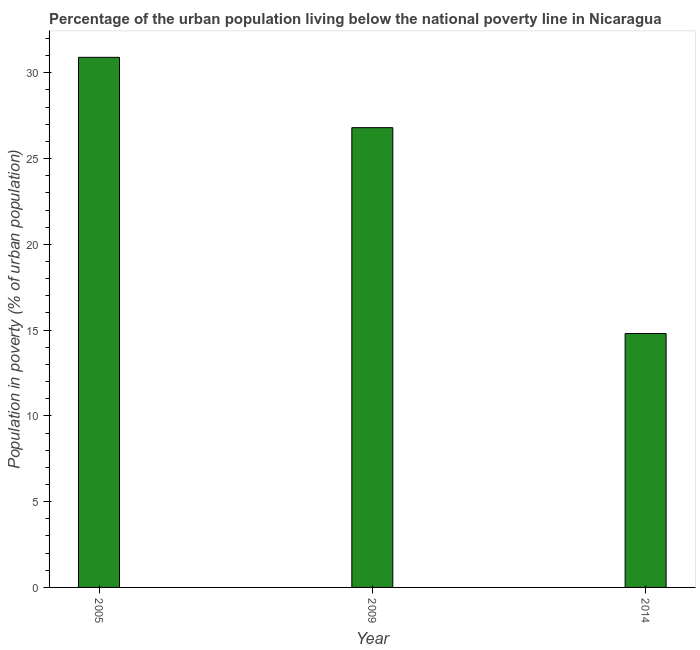What is the title of the graph?
Ensure brevity in your answer.  Percentage of the urban population living below the national poverty line in Nicaragua. What is the label or title of the Y-axis?
Offer a very short reply. Population in poverty (% of urban population). What is the percentage of urban population living below poverty line in 2009?
Ensure brevity in your answer.  26.8. Across all years, what is the maximum percentage of urban population living below poverty line?
Make the answer very short. 30.9. Across all years, what is the minimum percentage of urban population living below poverty line?
Your answer should be compact. 14.8. In which year was the percentage of urban population living below poverty line maximum?
Make the answer very short. 2005. What is the sum of the percentage of urban population living below poverty line?
Your response must be concise. 72.5. What is the difference between the percentage of urban population living below poverty line in 2009 and 2014?
Keep it short and to the point. 12. What is the average percentage of urban population living below poverty line per year?
Make the answer very short. 24.17. What is the median percentage of urban population living below poverty line?
Your answer should be very brief. 26.8. What is the ratio of the percentage of urban population living below poverty line in 2005 to that in 2014?
Provide a short and direct response. 2.09. Is the percentage of urban population living below poverty line in 2009 less than that in 2014?
Provide a short and direct response. No. Is the sum of the percentage of urban population living below poverty line in 2005 and 2009 greater than the maximum percentage of urban population living below poverty line across all years?
Offer a terse response. Yes. What is the difference between the highest and the lowest percentage of urban population living below poverty line?
Provide a succinct answer. 16.1. Are all the bars in the graph horizontal?
Your response must be concise. No. How many years are there in the graph?
Your response must be concise. 3. What is the difference between two consecutive major ticks on the Y-axis?
Make the answer very short. 5. Are the values on the major ticks of Y-axis written in scientific E-notation?
Offer a very short reply. No. What is the Population in poverty (% of urban population) in 2005?
Your answer should be compact. 30.9. What is the Population in poverty (% of urban population) of 2009?
Offer a very short reply. 26.8. What is the Population in poverty (% of urban population) of 2014?
Your answer should be compact. 14.8. What is the difference between the Population in poverty (% of urban population) in 2005 and 2009?
Ensure brevity in your answer.  4.1. What is the difference between the Population in poverty (% of urban population) in 2005 and 2014?
Offer a very short reply. 16.1. What is the ratio of the Population in poverty (% of urban population) in 2005 to that in 2009?
Offer a very short reply. 1.15. What is the ratio of the Population in poverty (% of urban population) in 2005 to that in 2014?
Keep it short and to the point. 2.09. What is the ratio of the Population in poverty (% of urban population) in 2009 to that in 2014?
Offer a terse response. 1.81. 